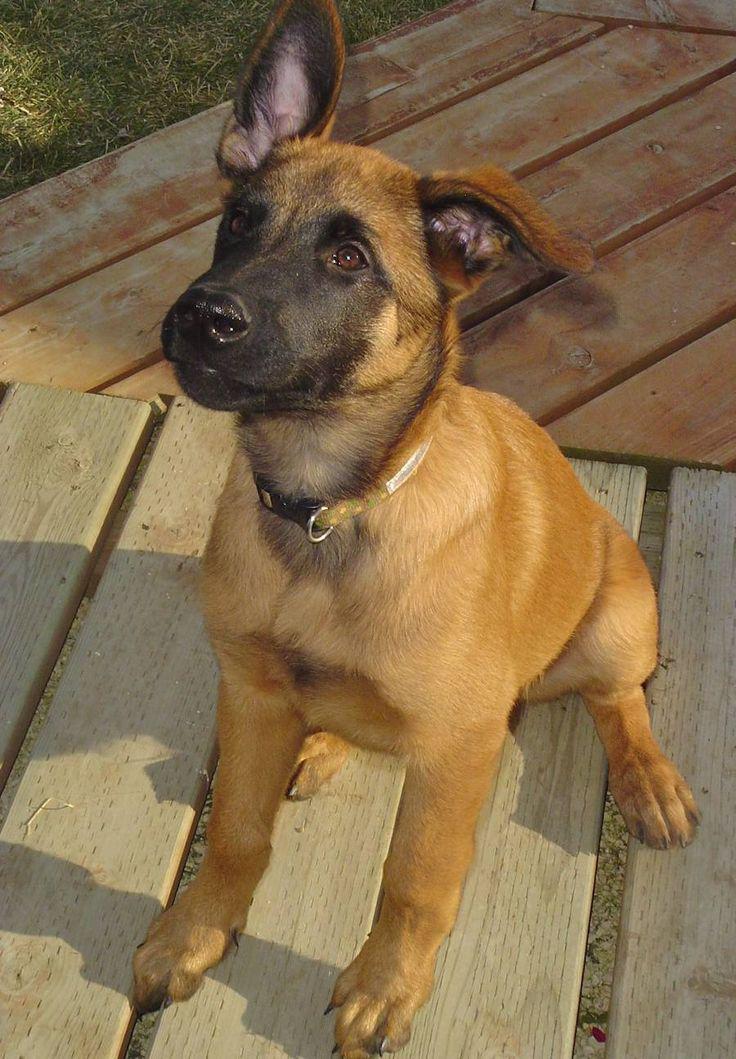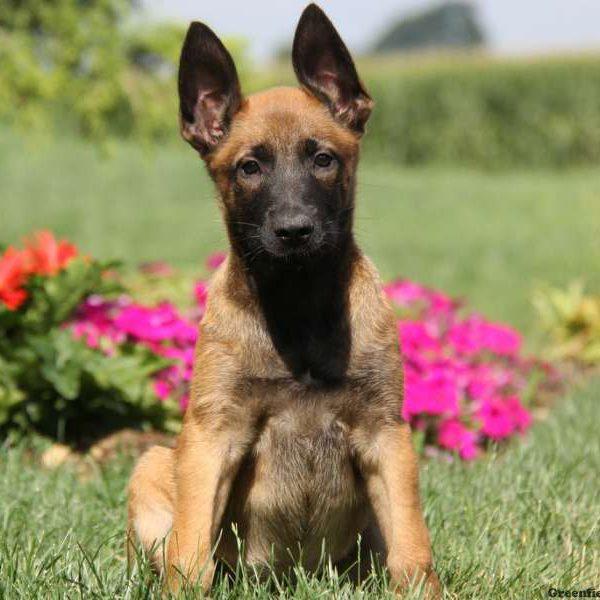The first image is the image on the left, the second image is the image on the right. For the images shown, is this caption "A dog is carrying something in its mouth" true? Answer yes or no. No. The first image is the image on the left, the second image is the image on the right. Analyze the images presented: Is the assertion "the puppy is sitting on a wooden platform" valid? Answer yes or no. Yes. 